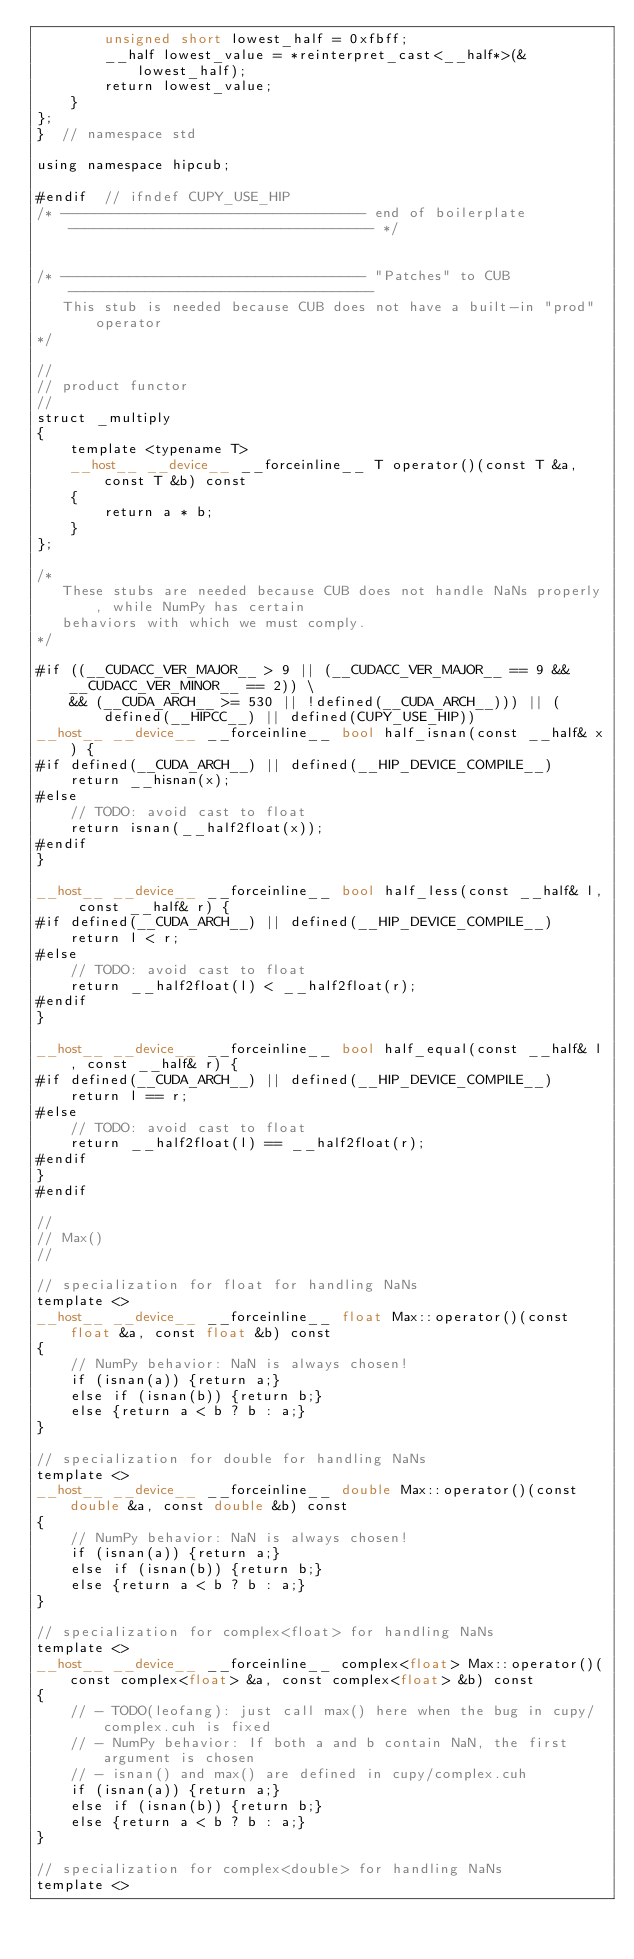<code> <loc_0><loc_0><loc_500><loc_500><_Cuda_>        unsigned short lowest_half = 0xfbff;
        __half lowest_value = *reinterpret_cast<__half*>(&lowest_half);
        return lowest_value;
    }
};
}  // namespace std

using namespace hipcub;

#endif  // ifndef CUPY_USE_HIP
/* ------------------------------------ end of boilerplate ------------------------------------ */


/* ------------------------------------ "Patches" to CUB ------------------------------------
   This stub is needed because CUB does not have a built-in "prod" operator
*/

//
// product functor
//
struct _multiply
{
    template <typename T>
    __host__ __device__ __forceinline__ T operator()(const T &a, const T &b) const
    {
        return a * b;
    }
};

/*
   These stubs are needed because CUB does not handle NaNs properly, while NumPy has certain
   behaviors with which we must comply.
*/

#if ((__CUDACC_VER_MAJOR__ > 9 || (__CUDACC_VER_MAJOR__ == 9 && __CUDACC_VER_MINOR__ == 2)) \
    && (__CUDA_ARCH__ >= 530 || !defined(__CUDA_ARCH__))) || (defined(__HIPCC__) || defined(CUPY_USE_HIP))
__host__ __device__ __forceinline__ bool half_isnan(const __half& x) {
#if defined(__CUDA_ARCH__) || defined(__HIP_DEVICE_COMPILE__)
    return __hisnan(x);
#else
    // TODO: avoid cast to float
    return isnan(__half2float(x));
#endif
}

__host__ __device__ __forceinline__ bool half_less(const __half& l, const __half& r) {
#if defined(__CUDA_ARCH__) || defined(__HIP_DEVICE_COMPILE__)
    return l < r;
#else
    // TODO: avoid cast to float
    return __half2float(l) < __half2float(r);
#endif
}

__host__ __device__ __forceinline__ bool half_equal(const __half& l, const __half& r) {
#if defined(__CUDA_ARCH__) || defined(__HIP_DEVICE_COMPILE__)
    return l == r;
#else
    // TODO: avoid cast to float
    return __half2float(l) == __half2float(r);
#endif
}
#endif

//
// Max()
//

// specialization for float for handling NaNs
template <>
__host__ __device__ __forceinline__ float Max::operator()(const float &a, const float &b) const
{
    // NumPy behavior: NaN is always chosen!
    if (isnan(a)) {return a;}
    else if (isnan(b)) {return b;}
    else {return a < b ? b : a;}
}

// specialization for double for handling NaNs
template <>
__host__ __device__ __forceinline__ double Max::operator()(const double &a, const double &b) const
{
    // NumPy behavior: NaN is always chosen!
    if (isnan(a)) {return a;}
    else if (isnan(b)) {return b;}
    else {return a < b ? b : a;}
}

// specialization for complex<float> for handling NaNs
template <>
__host__ __device__ __forceinline__ complex<float> Max::operator()(const complex<float> &a, const complex<float> &b) const
{
    // - TODO(leofang): just call max() here when the bug in cupy/complex.cuh is fixed
    // - NumPy behavior: If both a and b contain NaN, the first argument is chosen
    // - isnan() and max() are defined in cupy/complex.cuh
    if (isnan(a)) {return a;}
    else if (isnan(b)) {return b;}
    else {return a < b ? b : a;}
}

// specialization for complex<double> for handling NaNs
template <></code> 